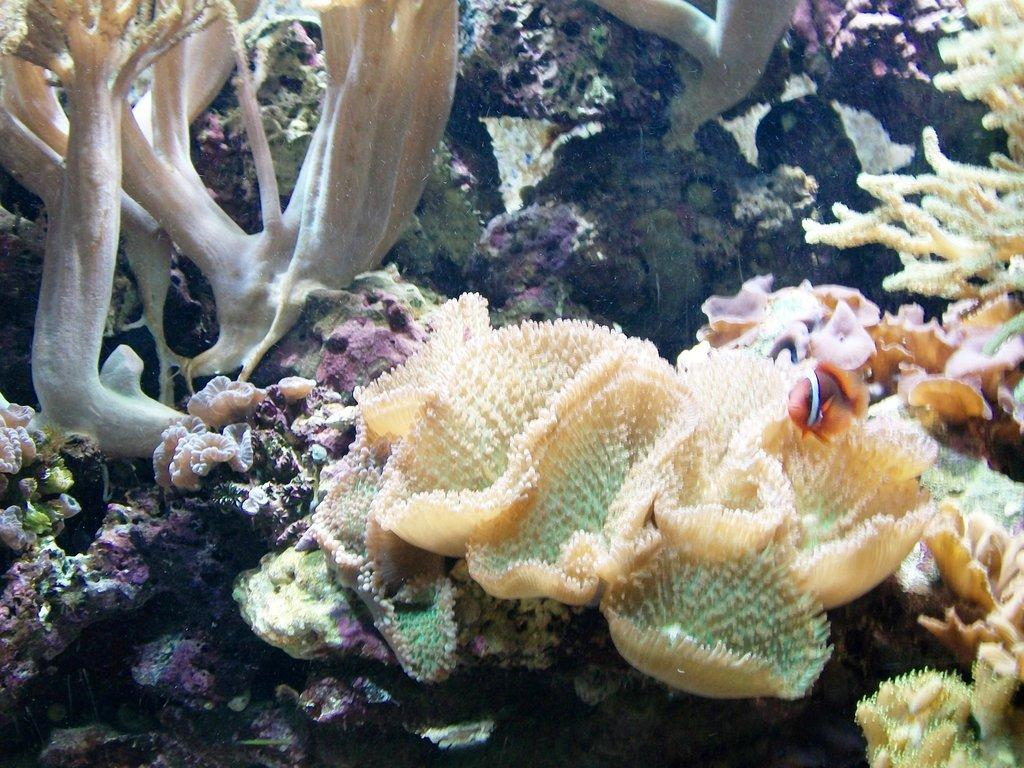What type of underwater environment is depicted in the image? The image features corals, marine plants, and fishes, indicating an underwater environment. Can you describe the marine life present in the image? There are corals, marine plants, and fishes visible in the image. What is the primary substance surrounding the marine life in the image? Water is visible in the image, surrounding the corals, marine plants, and fishes. What type of orange is being used as a bed for the fishes in the image? There is no orange or bed present in the image; it features an underwater environment with corals, marine plants, and fishes. 